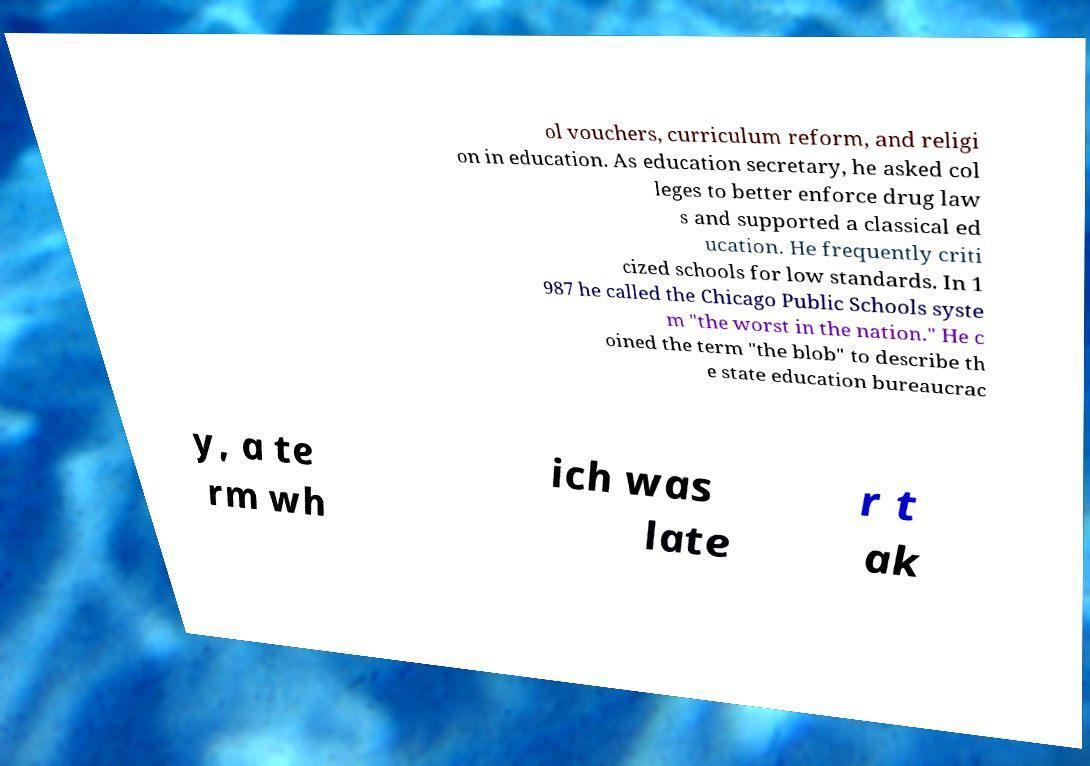Could you assist in decoding the text presented in this image and type it out clearly? ol vouchers, curriculum reform, and religi on in education. As education secretary, he asked col leges to better enforce drug law s and supported a classical ed ucation. He frequently criti cized schools for low standards. In 1 987 he called the Chicago Public Schools syste m "the worst in the nation." He c oined the term "the blob" to describe th e state education bureaucrac y, a te rm wh ich was late r t ak 